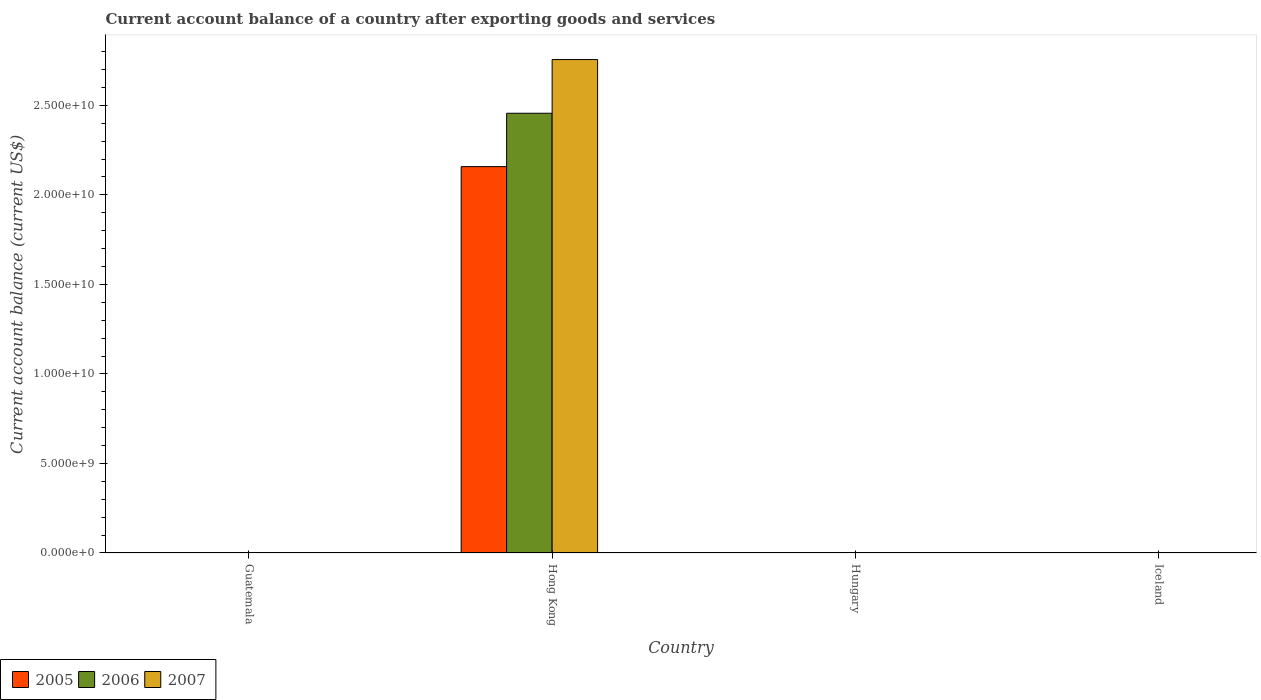Are the number of bars on each tick of the X-axis equal?
Ensure brevity in your answer.  No. How many bars are there on the 3rd tick from the left?
Make the answer very short. 0. How many bars are there on the 2nd tick from the right?
Offer a very short reply. 0. What is the label of the 4th group of bars from the left?
Your response must be concise. Iceland. In how many cases, is the number of bars for a given country not equal to the number of legend labels?
Provide a succinct answer. 3. What is the account balance in 2006 in Guatemala?
Make the answer very short. 0. Across all countries, what is the maximum account balance in 2007?
Keep it short and to the point. 2.76e+1. Across all countries, what is the minimum account balance in 2007?
Offer a very short reply. 0. In which country was the account balance in 2005 maximum?
Keep it short and to the point. Hong Kong. What is the total account balance in 2007 in the graph?
Ensure brevity in your answer.  2.76e+1. What is the difference between the account balance in 2007 in Guatemala and the account balance in 2006 in Hong Kong?
Offer a very short reply. -2.46e+1. What is the average account balance in 2005 per country?
Provide a short and direct response. 5.39e+09. What is the difference between the account balance of/in 2007 and account balance of/in 2005 in Hong Kong?
Offer a very short reply. 5.98e+09. In how many countries, is the account balance in 2005 greater than 20000000000 US$?
Give a very brief answer. 1. What is the difference between the highest and the lowest account balance in 2005?
Your response must be concise. 2.16e+1. Is it the case that in every country, the sum of the account balance in 2006 and account balance in 2005 is greater than the account balance in 2007?
Your answer should be very brief. No. How many bars are there?
Make the answer very short. 3. What is the difference between two consecutive major ticks on the Y-axis?
Provide a short and direct response. 5.00e+09. Where does the legend appear in the graph?
Make the answer very short. Bottom left. How many legend labels are there?
Provide a short and direct response. 3. How are the legend labels stacked?
Your answer should be very brief. Horizontal. What is the title of the graph?
Your answer should be compact. Current account balance of a country after exporting goods and services. What is the label or title of the X-axis?
Your response must be concise. Country. What is the label or title of the Y-axis?
Provide a succinct answer. Current account balance (current US$). What is the Current account balance (current US$) in 2005 in Guatemala?
Provide a short and direct response. 0. What is the Current account balance (current US$) in 2006 in Guatemala?
Offer a terse response. 0. What is the Current account balance (current US$) of 2005 in Hong Kong?
Your answer should be compact. 2.16e+1. What is the Current account balance (current US$) of 2006 in Hong Kong?
Give a very brief answer. 2.46e+1. What is the Current account balance (current US$) in 2007 in Hong Kong?
Ensure brevity in your answer.  2.76e+1. What is the Current account balance (current US$) of 2005 in Hungary?
Offer a terse response. 0. What is the Current account balance (current US$) in 2007 in Hungary?
Ensure brevity in your answer.  0. What is the Current account balance (current US$) of 2005 in Iceland?
Give a very brief answer. 0. What is the Current account balance (current US$) in 2006 in Iceland?
Provide a succinct answer. 0. Across all countries, what is the maximum Current account balance (current US$) in 2005?
Your response must be concise. 2.16e+1. Across all countries, what is the maximum Current account balance (current US$) of 2006?
Your answer should be very brief. 2.46e+1. Across all countries, what is the maximum Current account balance (current US$) of 2007?
Keep it short and to the point. 2.76e+1. Across all countries, what is the minimum Current account balance (current US$) of 2007?
Your response must be concise. 0. What is the total Current account balance (current US$) of 2005 in the graph?
Your answer should be compact. 2.16e+1. What is the total Current account balance (current US$) of 2006 in the graph?
Make the answer very short. 2.46e+1. What is the total Current account balance (current US$) of 2007 in the graph?
Keep it short and to the point. 2.76e+1. What is the average Current account balance (current US$) of 2005 per country?
Offer a very short reply. 5.39e+09. What is the average Current account balance (current US$) of 2006 per country?
Offer a terse response. 6.14e+09. What is the average Current account balance (current US$) of 2007 per country?
Provide a succinct answer. 6.89e+09. What is the difference between the Current account balance (current US$) in 2005 and Current account balance (current US$) in 2006 in Hong Kong?
Your response must be concise. -2.98e+09. What is the difference between the Current account balance (current US$) in 2005 and Current account balance (current US$) in 2007 in Hong Kong?
Make the answer very short. -5.98e+09. What is the difference between the Current account balance (current US$) in 2006 and Current account balance (current US$) in 2007 in Hong Kong?
Your response must be concise. -3.00e+09. What is the difference between the highest and the lowest Current account balance (current US$) of 2005?
Keep it short and to the point. 2.16e+1. What is the difference between the highest and the lowest Current account balance (current US$) of 2006?
Your response must be concise. 2.46e+1. What is the difference between the highest and the lowest Current account balance (current US$) in 2007?
Make the answer very short. 2.76e+1. 